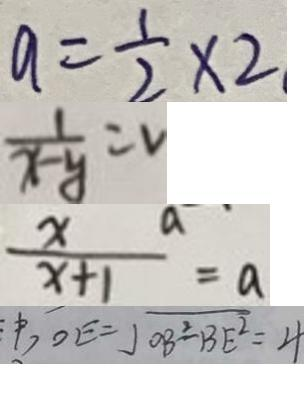<formula> <loc_0><loc_0><loc_500><loc_500>a = \frac { 1 } { 2 } \times 2 
 \frac { 1 } { x - y } = v 
 \frac { x a } { x + 1 } = a 
 O E = \sqrt { O B ^ { 2 } - B E ^ { 2 } } = 4</formula> 